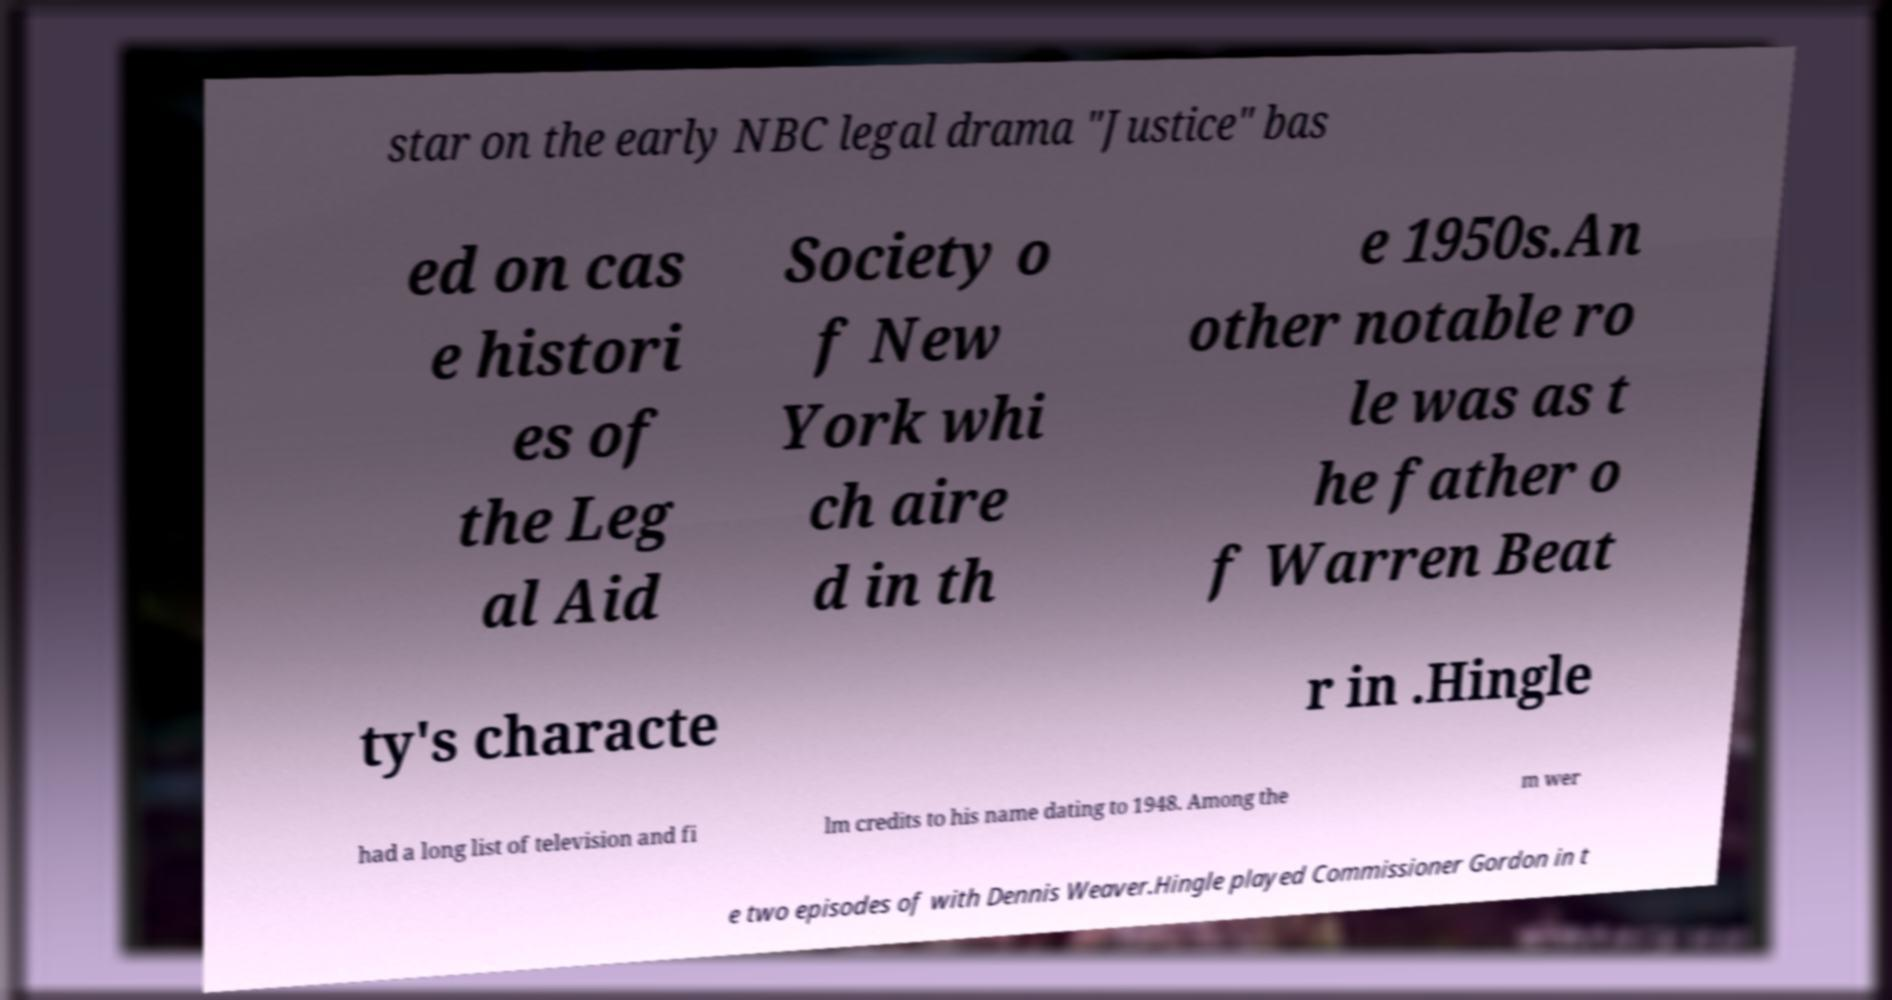There's text embedded in this image that I need extracted. Can you transcribe it verbatim? star on the early NBC legal drama "Justice" bas ed on cas e histori es of the Leg al Aid Society o f New York whi ch aire d in th e 1950s.An other notable ro le was as t he father o f Warren Beat ty's characte r in .Hingle had a long list of television and fi lm credits to his name dating to 1948. Among the m wer e two episodes of with Dennis Weaver.Hingle played Commissioner Gordon in t 